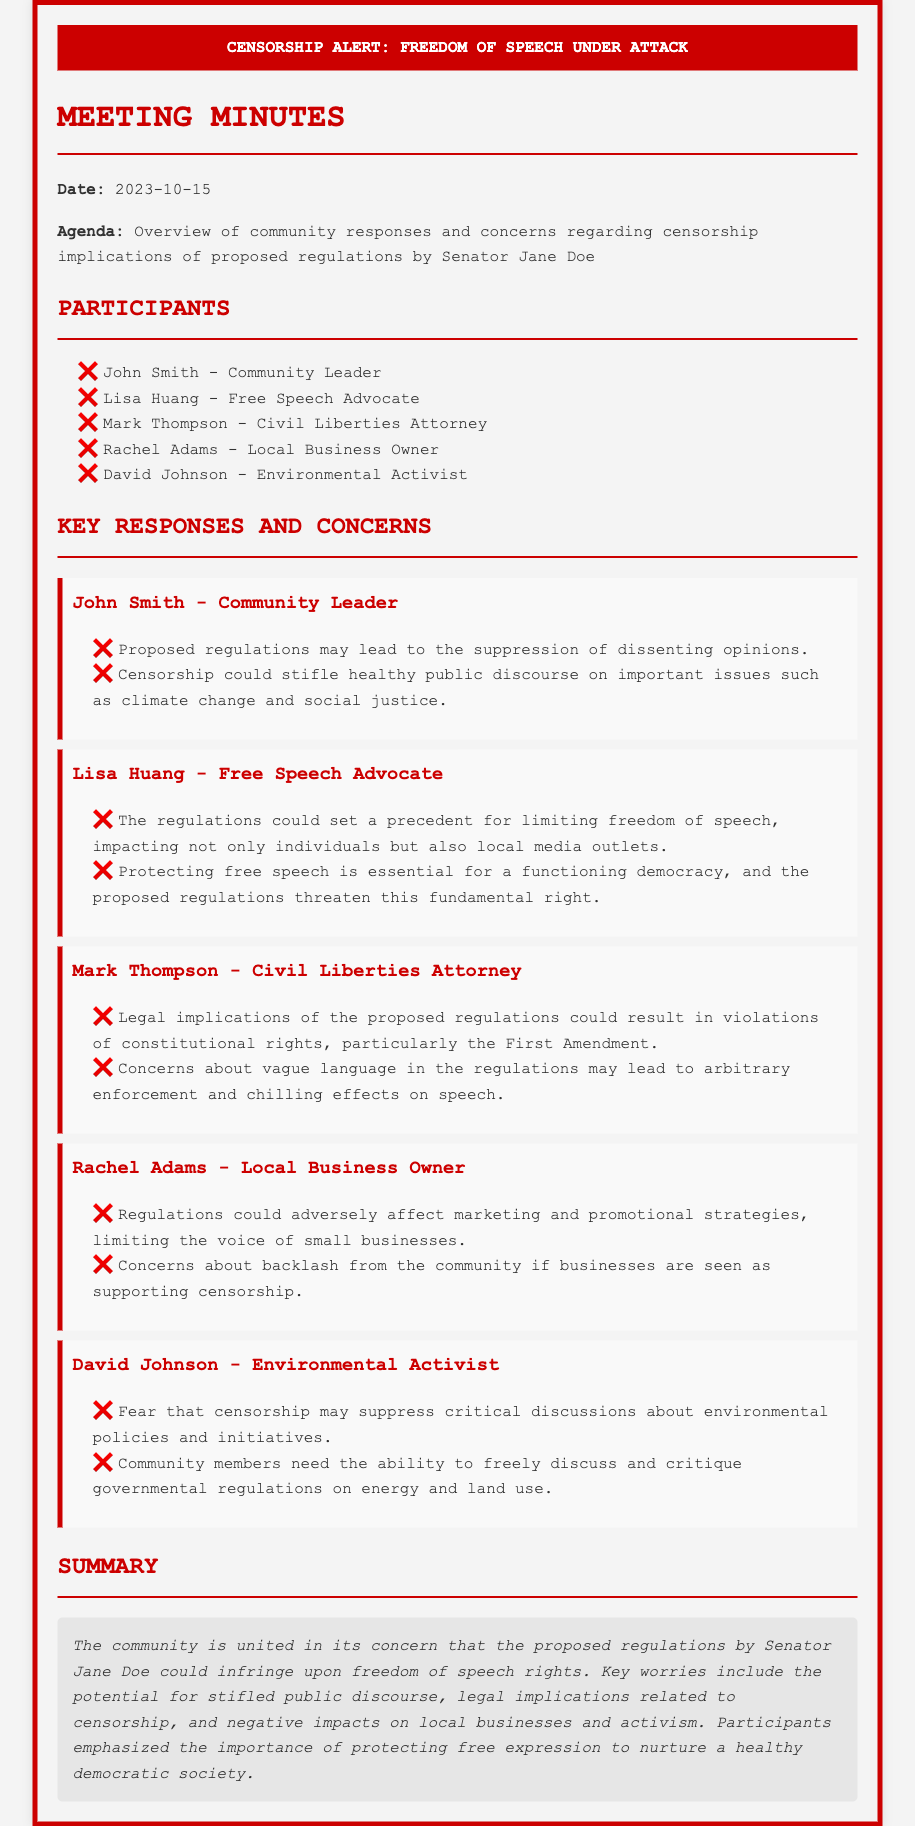what is the date of the meeting? The date of the meeting is explicitly stated at the beginning of the document.
Answer: 2023-10-15 who is the senator associated with the proposed regulations? The name of the senator is mentioned in the agenda section of the document.
Answer: Senator Jane Doe what was one of John Smith's concerns? John Smith's concerns can be found in his specific statements listed under his name.
Answer: Suppression of dissenting opinions which constitutional right is specifically mentioned by Mark Thompson? The constitutional right mentioned can be found in Mark Thompson's concerns regarding the proposed regulations.
Answer: First Amendment how many participants were listed in the meeting? The total number of participants can be counted from the list provided in the document.
Answer: 5 what is the overarching theme of the community's concerns? The summary section provides insight into the primary theme of concerns discussed during the meeting.
Answer: Censorship implications which participant is a civil liberties attorney? The occupation of participants is provided next to their names, allowing for easy identification.
Answer: Mark Thompson what could regulations negatively impact according to Rachel Adams? Rachel Adams specifies the area of impact regarding the proposed regulations in her concerns.
Answer: Marketing and promotional strategies 